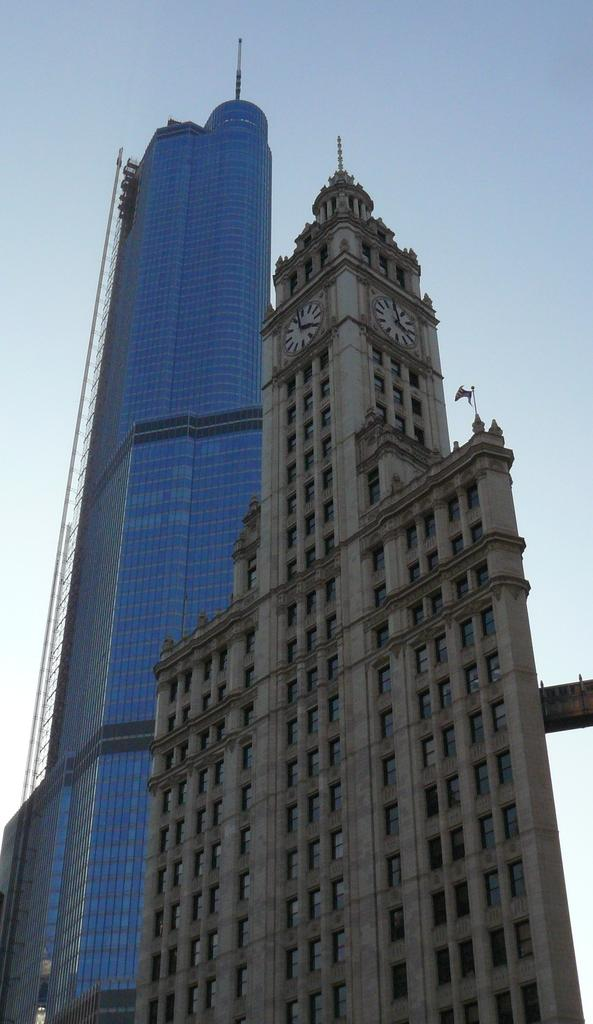What type of structures are present in the image? There are buildings with windows in the image. What time-telling device can be seen in the image? There is a clock in the image. What part of the natural environment is visible in the image? The sky is visible in the image. Can you see an uncle standing on a mountain in the image? There is no mountain or uncle present in the image. 